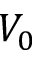Convert formula to latex. <formula><loc_0><loc_0><loc_500><loc_500>V _ { 0 }</formula> 